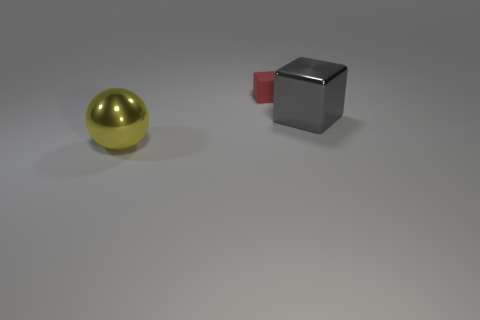Add 2 green shiny spheres. How many objects exist? 5 Subtract all balls. How many objects are left? 2 Subtract 0 cyan balls. How many objects are left? 3 Subtract all big gray metallic cylinders. Subtract all rubber things. How many objects are left? 2 Add 2 red things. How many red things are left? 3 Add 3 yellow shiny objects. How many yellow shiny objects exist? 4 